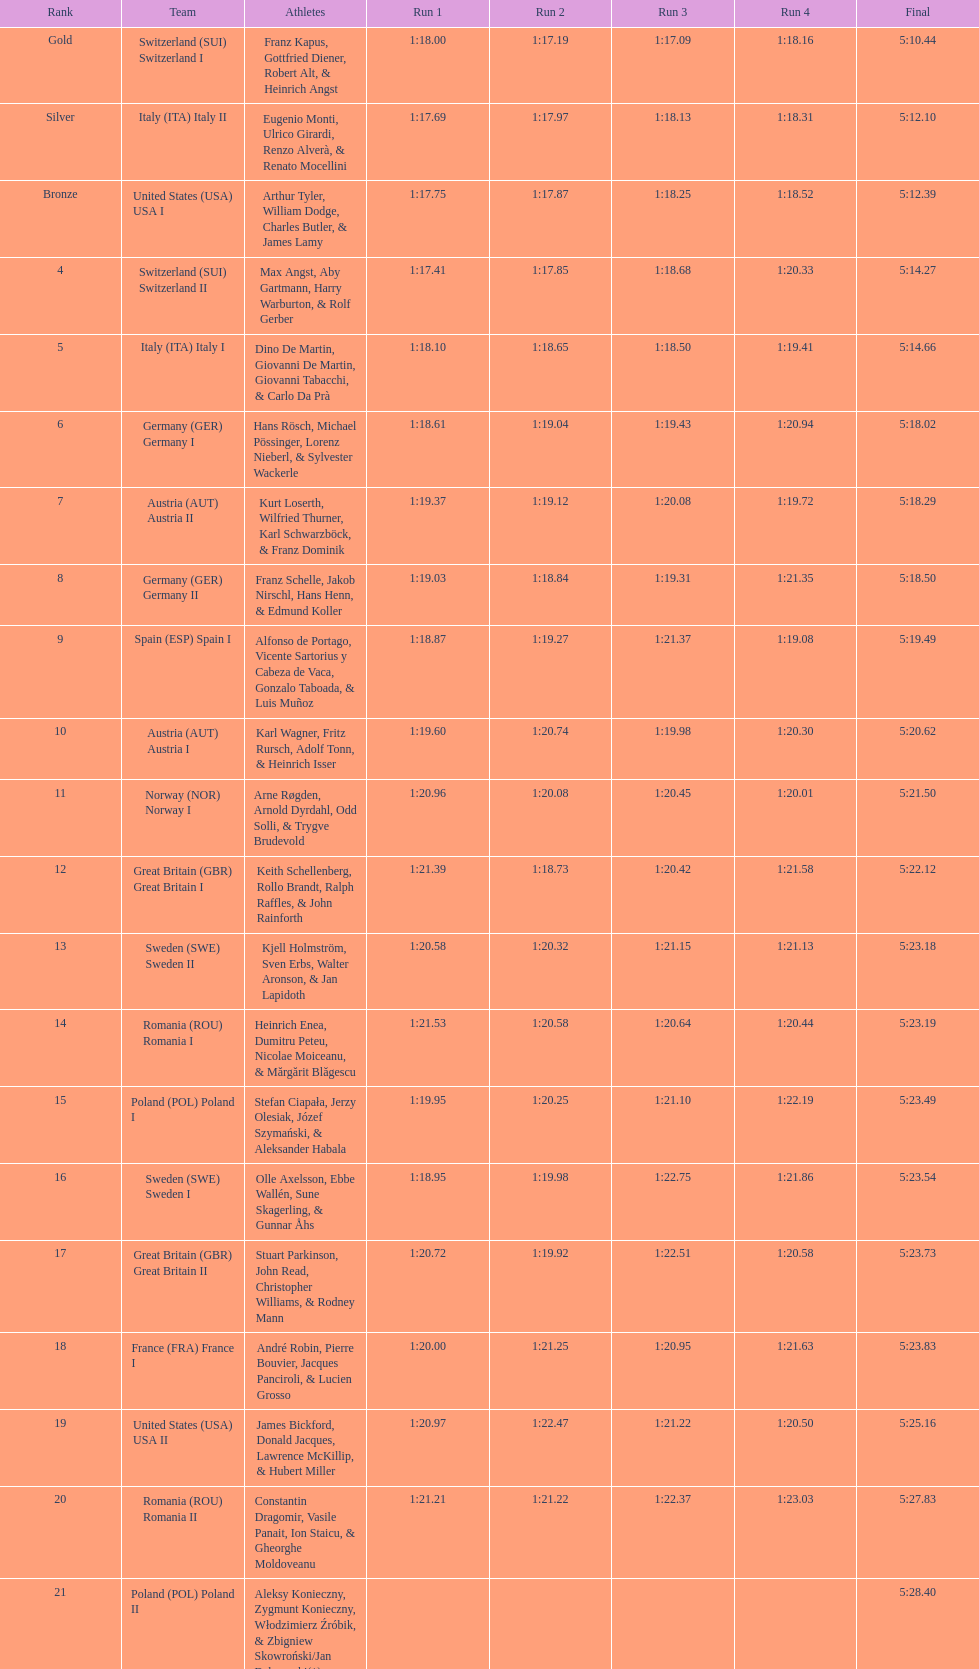Who is the prior team to italy (ita) italy ii? Switzerland (SUI) Switzerland I. 